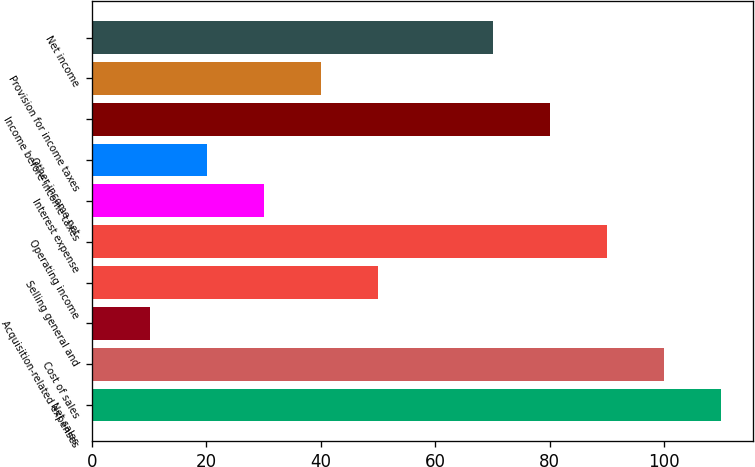Convert chart. <chart><loc_0><loc_0><loc_500><loc_500><bar_chart><fcel>Net sales<fcel>Cost of sales<fcel>Acquisition-related expenses<fcel>Selling general and<fcel>Operating income<fcel>Interest expense<fcel>Other income net<fcel>Income before income taxes<fcel>Provision for income taxes<fcel>Net income<nl><fcel>109.99<fcel>100<fcel>10.09<fcel>50.05<fcel>90.01<fcel>30.07<fcel>20.08<fcel>80.02<fcel>40.06<fcel>70.03<nl></chart> 